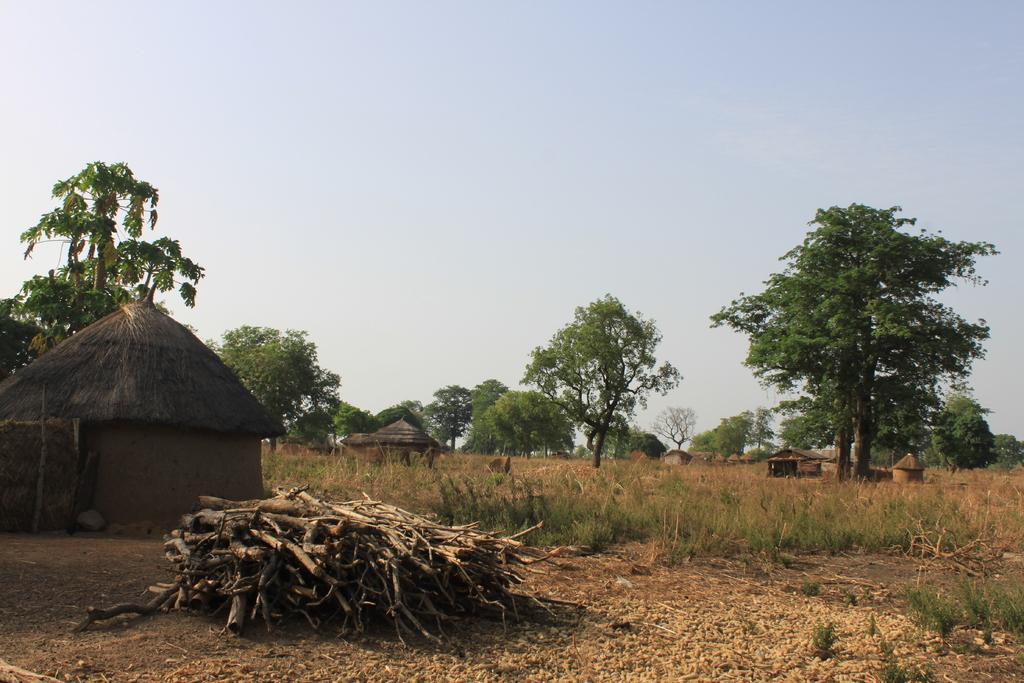In one or two sentences, can you explain what this image depicts? In this image we can see the huts, trees, plants and twigs. At the top we can see the sky. 